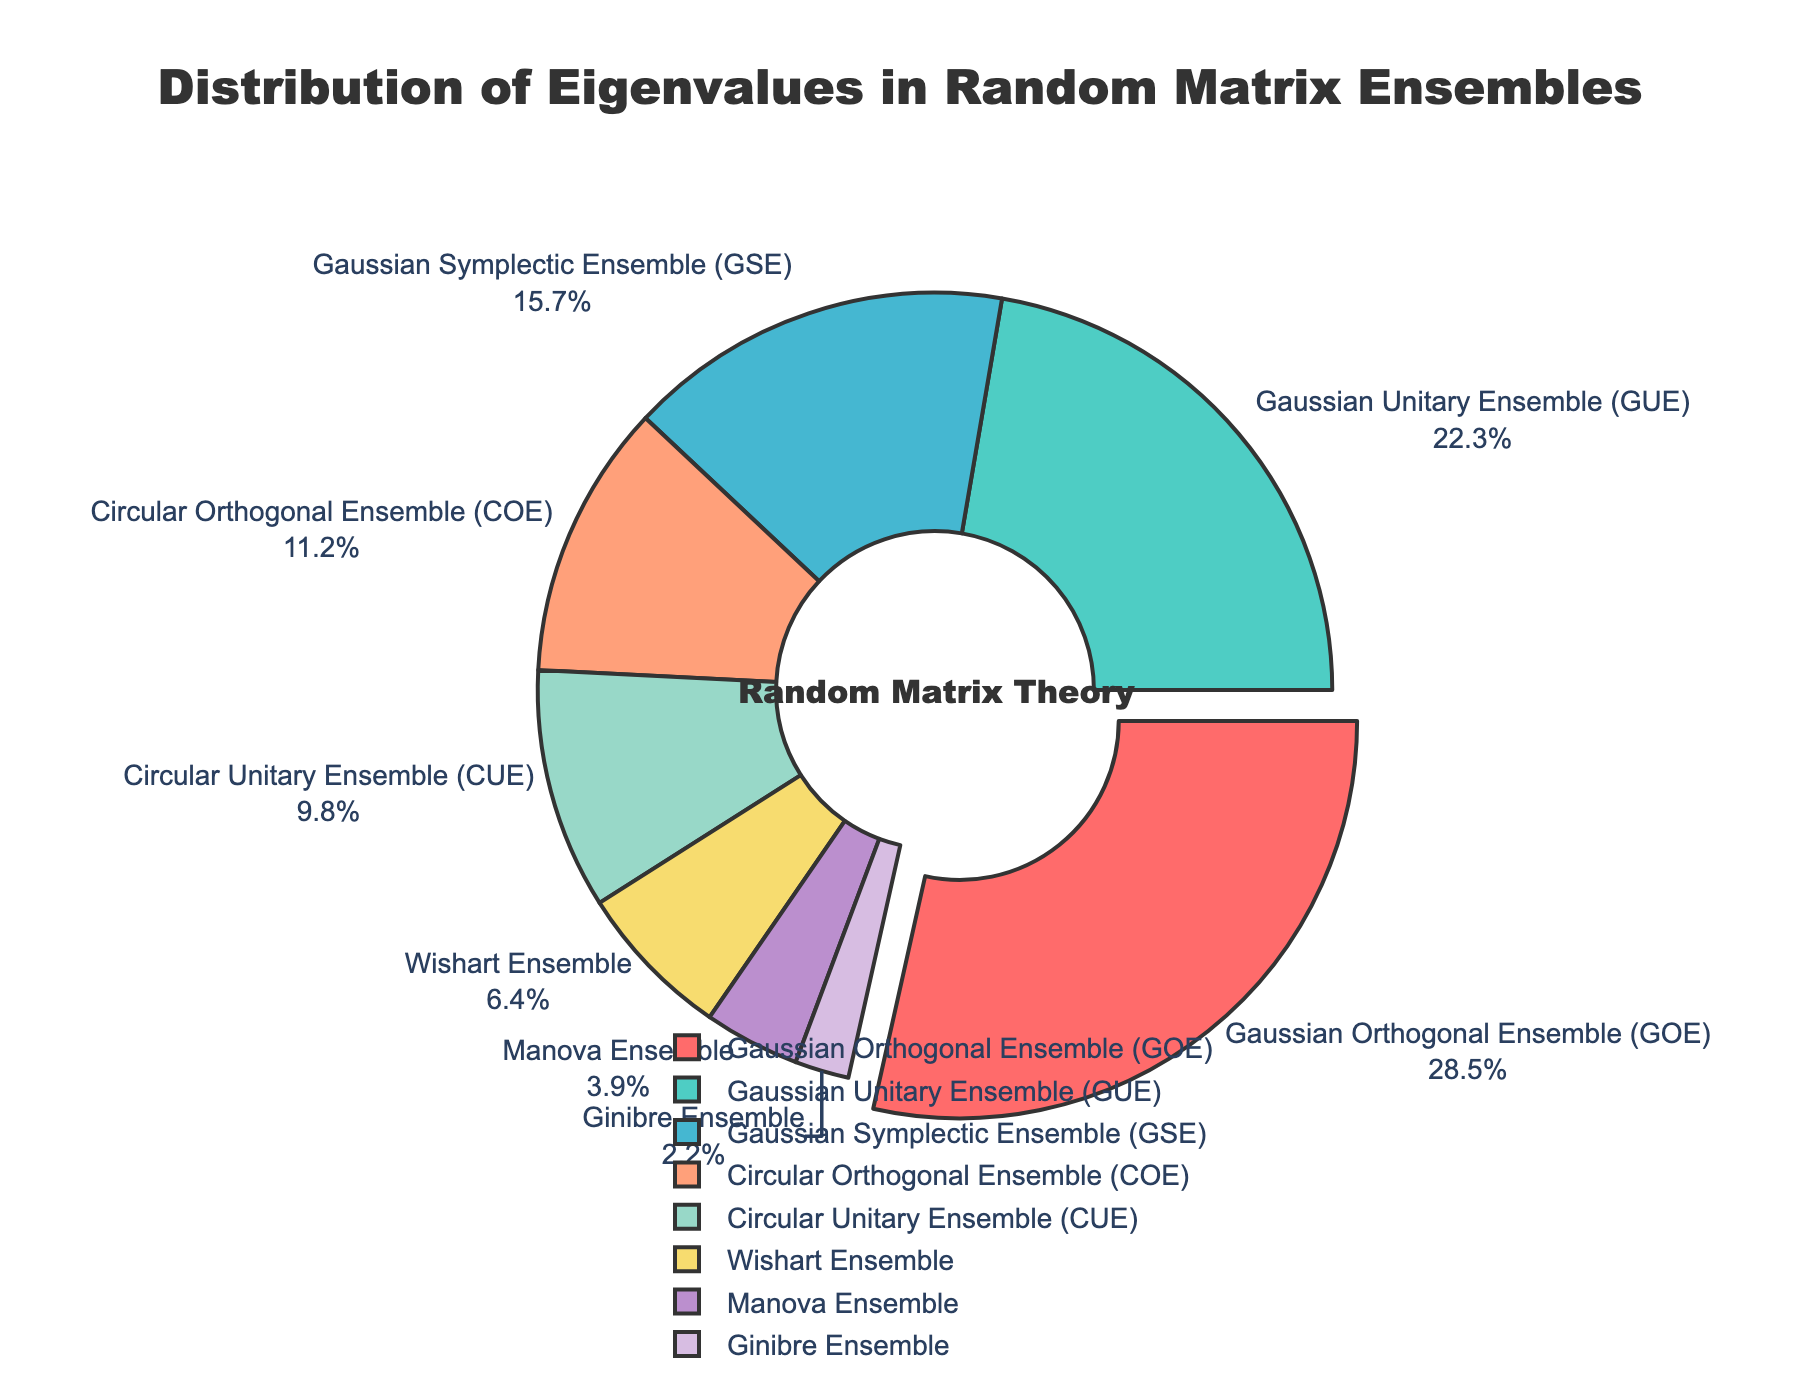Which ensemble has the highest percentage of eigenvalues? The question requires identifying the ensemble with the largest sector in the pie chart. The largest sector visually is the "Gaussian Orthogonal Ensemble (GOE)" with 28.5%.
Answer: Gaussian Orthogonal Ensemble (GOE) How much more percentage does the Gaussian Orthogonal Ensemble (GOE) have compared to the Circular Orthogonal Ensemble (COE)? Subtract the percentage of the Circular Orthogonal Ensemble (COE), which is 11.2%, from that of the Gaussian Orthogonal Ensemble (GOE), which is 28.5%. The difference is 28.5% - 11.2%.
Answer: 17.3% Which ensembles collectively form more than 50% of the eigenvalues distribution? Add the percentages of the top ensembles until the sum exceeds 50%. Starting from the largest: GOE (28.5%) + GUE (22.3%) = 50.8%. Together, these two ensembles form more than 50%.
Answer: Gaussian Orthogonal Ensemble (GOE) and Gaussian Unitary Ensemble (GUE) What is the average percentage of the Gaussian Unitary Ensemble (GUE) and Gaussian Symplectic Ensemble (GSE)? Calculate the average by summing the percentages of GUE (22.3%) and GSE (15.7%), and then dividing by 2. (22.3% + 15.7%) / 2.
Answer: 19.0% How does the percentage of the Wishart Ensemble compare to that of the Manova Ensemble? The Wishart Ensemble has a percentage of 6.4% and the Manova Ensemble has 3.9%. Comparing these percentages, Wishart is greater than Manova.
Answer: Wishart Ensemble is greater Which ensemble is represented by the color #FFA07A? The pie chart uses different colors for different ensembles. To find the specific color, locate the ensemble using #FFA07A visually. This corresponds to the "Circular Orthogonal Ensemble (COE)".
Answer: Circular Orthogonal Ensemble (COE) What is the combined percentage of the Wishart Ensemble, Manova Ensemble, and Ginibre Ensemble? Sum the percentages of the Wishart Ensemble (6.4%), Manova Ensemble (3.9%), and Ginibre Ensemble (2.2%). (6.4% + 3.9% + 2.2%).
Answer: 12.5% Which ensemble has the smallest percentage of eigenvalues? Find the ensemble with the smallest section in the pie chart. The smallest section corresponds to the "Ginibre Ensemble" with 2.2%.
Answer: Ginibre Ensemble How does the percentage of the Circular Unitary Ensemble (CUE) compare to the Gaussian Symplectic Ensemble (GSE)? The CUE has 9.8%, while the GSE has 15.7%. Comparing these values, the GSE percentage is greater than the CUE percentage.
Answer: Gaussian Symplectic Ensemble (GSE) is greater What is the difference between the highest and lowest percentages in the distribution? Subtract the smallest percentage (Ginibre Ensemble, 2.2%) from the largest percentage (GOE, 28.5%). 28.5% - 2.2% = 26.3%.
Answer: 26.3% 